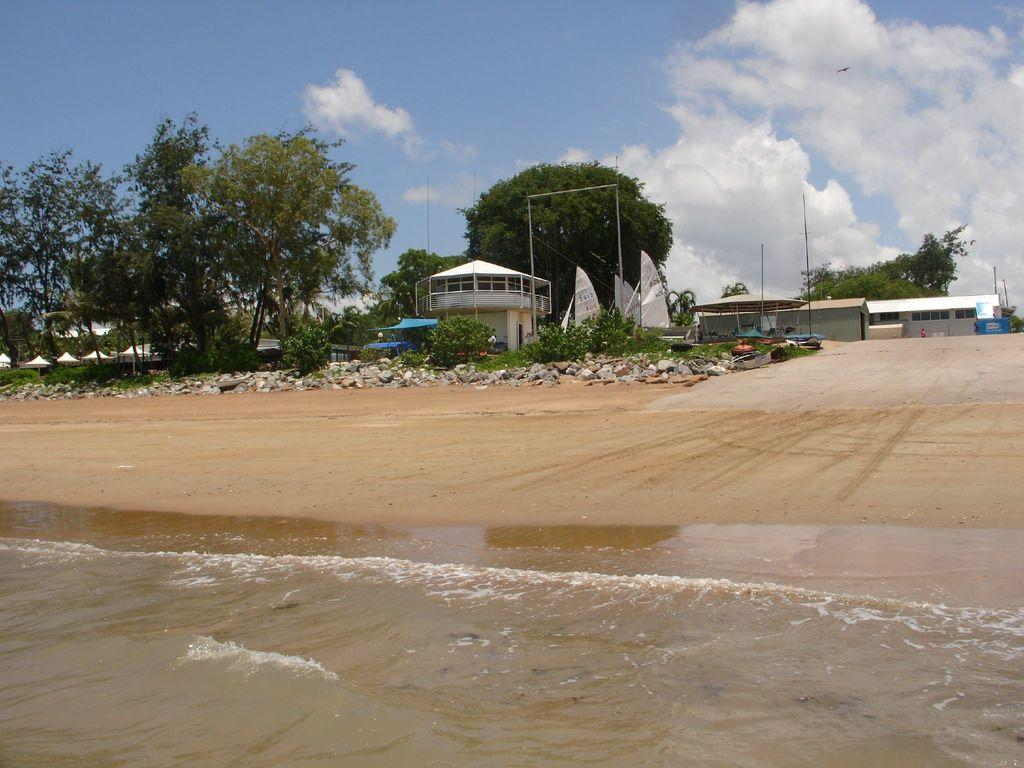What is in the foreground of the image? There is water and sand in the foreground of the image. What can be seen in the background of the image? In the background, there are boats, plants, trees, a building, poles, and the sky. Can you describe the sky in the image? The sky is visible in the background of the image, and there are clouds present. What type of appliance is being discussed by the pizzas in the image? There are no pizzas or discussions about appliances present in the image. 